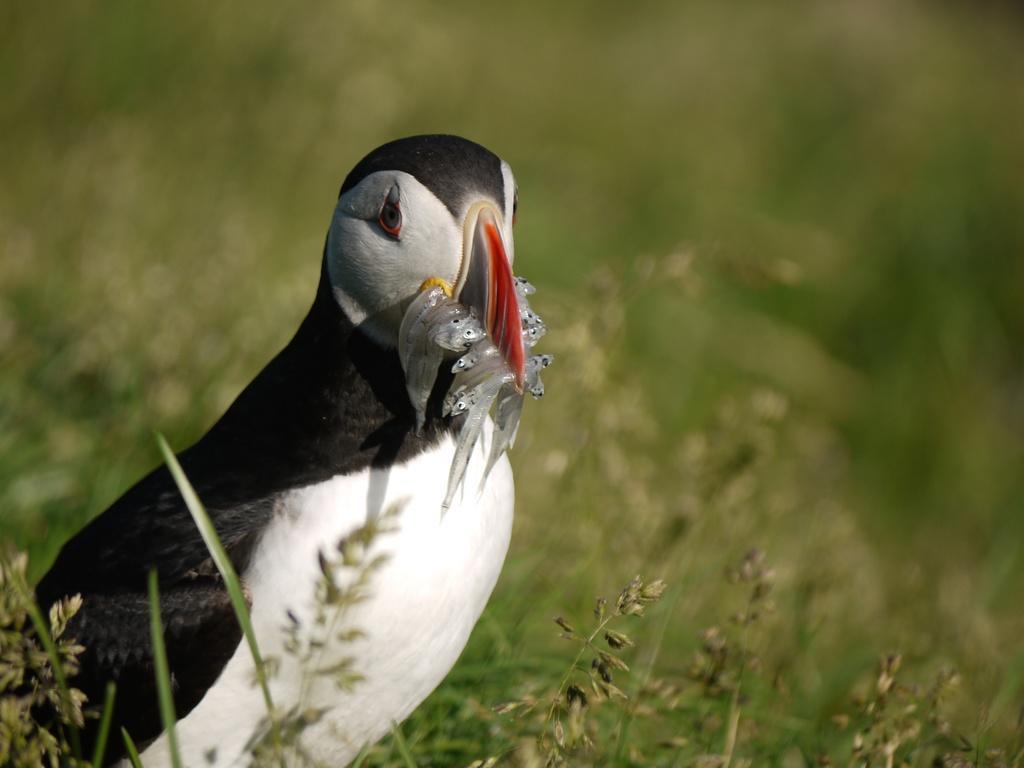How would you summarize this image in a sentence or two? In this image there is grass, behind that there is a bird in its beak there are fishes, in the background it is blurred. 